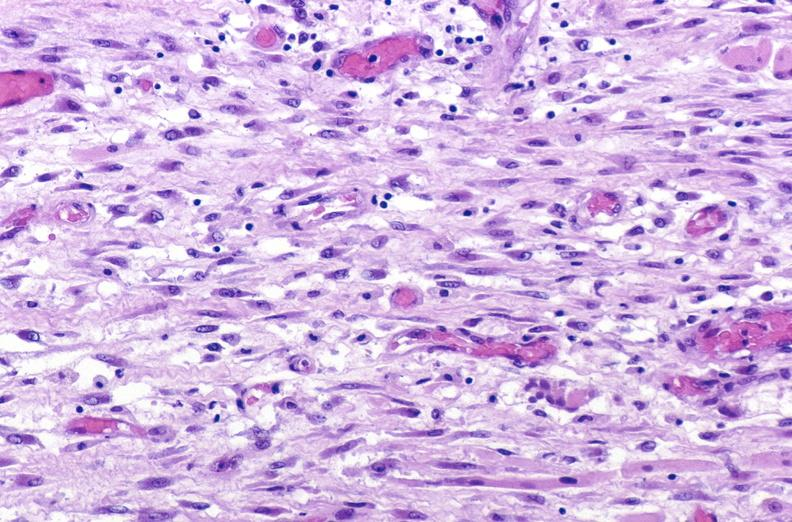what is present?
Answer the question using a single word or phrase. Soft tissue 